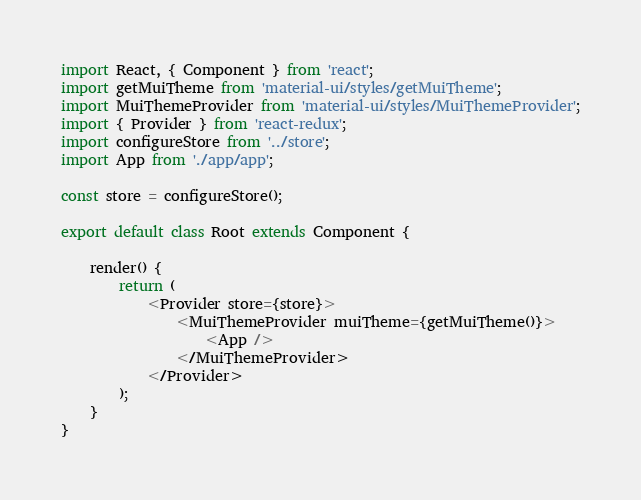Convert code to text. <code><loc_0><loc_0><loc_500><loc_500><_JavaScript_>import React, { Component } from 'react';
import getMuiTheme from 'material-ui/styles/getMuiTheme';
import MuiThemeProvider from 'material-ui/styles/MuiThemeProvider';
import { Provider } from 'react-redux';
import configureStore from '../store';
import App from './app/app';

const store = configureStore();

export default class Root extends Component {

    render() {
        return (
            <Provider store={store}>
                <MuiThemeProvider muiTheme={getMuiTheme()}>
                    <App />
                </MuiThemeProvider>
            </Provider>
        );
    }
}</code> 